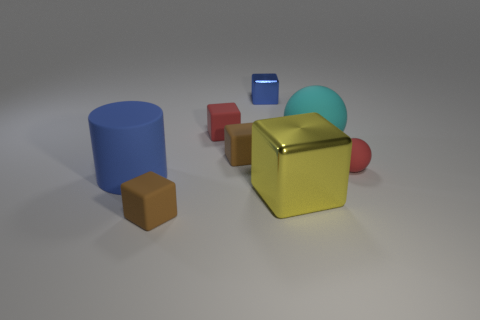Subtract all gray cylinders. How many brown cubes are left? 2 Subtract all yellow cubes. How many cubes are left? 4 Subtract all brown matte cubes. How many cubes are left? 3 Subtract 1 cubes. How many cubes are left? 4 Add 1 tiny brown things. How many objects exist? 9 Subtract all green blocks. Subtract all blue cylinders. How many blocks are left? 5 Subtract all cubes. How many objects are left? 3 Subtract 1 blue blocks. How many objects are left? 7 Subtract all tiny gray shiny objects. Subtract all brown cubes. How many objects are left? 6 Add 6 red rubber cubes. How many red rubber cubes are left? 7 